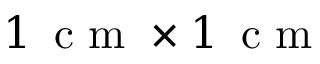Convert formula to latex. <formula><loc_0><loc_0><loc_500><loc_500>1 \, c m \times 1 \, c m</formula> 